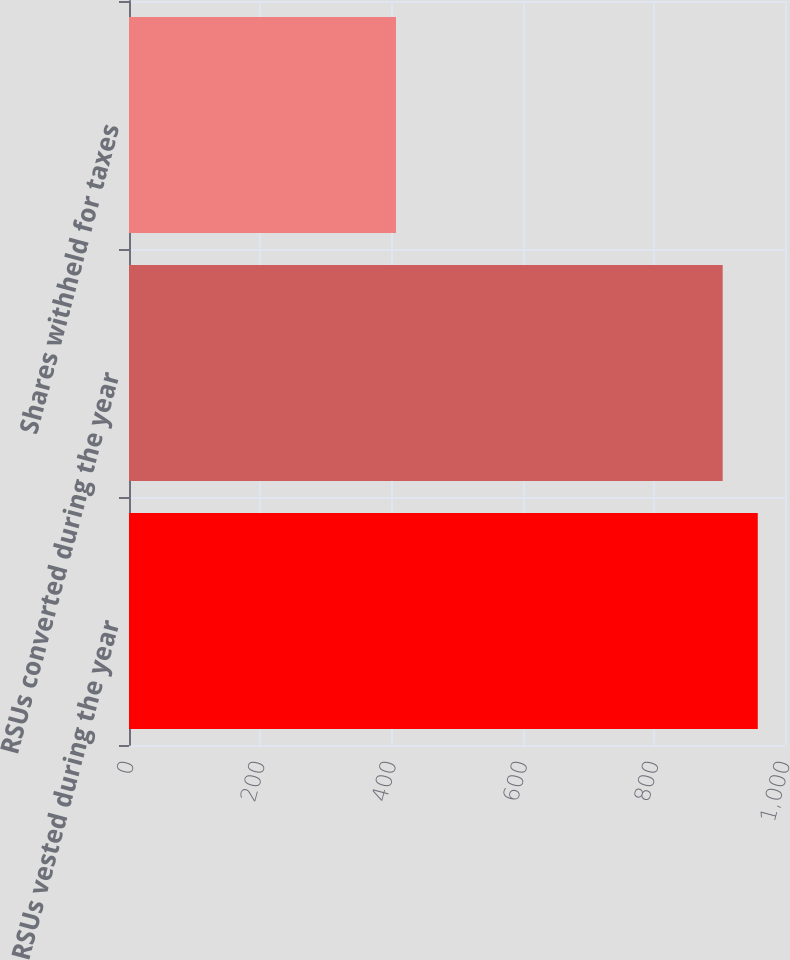Convert chart. <chart><loc_0><loc_0><loc_500><loc_500><bar_chart><fcel>RSUs vested during the year<fcel>RSUs converted during the year<fcel>Shares withheld for taxes<nl><fcel>958.5<fcel>905<fcel>407<nl></chart> 